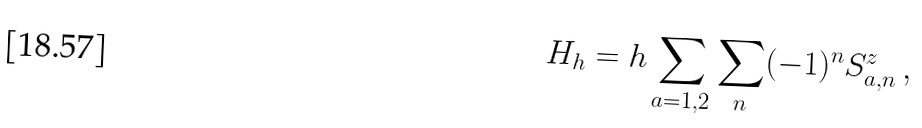Convert formula to latex. <formula><loc_0><loc_0><loc_500><loc_500>H _ { h } = h \sum _ { a = 1 , 2 } \sum _ { n } ( - 1 ) ^ { n } S _ { a , n } ^ { z } \, ,</formula> 